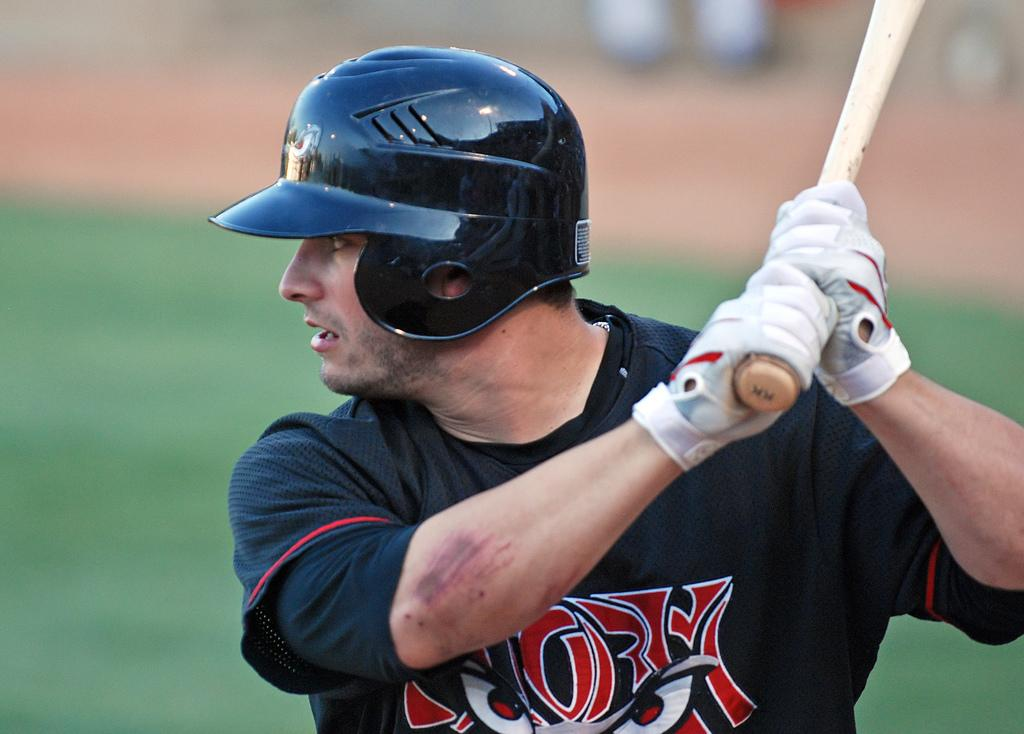What is the main subject of the image? There is a person in the image. What is the person wearing on their upper body? The person is wearing a black T-shirt. What protective gear is the person wearing? The person is wearing a helmet. What other accessory is the person wearing? The person is wearing gloves. What object is the person holding? The person is holding a baseball bat. What can be observed about the background of the image? The background of the image is blurred and green. What type of umbrella is the person holding in the image? There is no umbrella present in the image; the person is holding a baseball bat. What day of the week is depicted in the image? The image does not show a specific day of the week; it is a snapshot of a person wearing a helmet, gloves, and holding a baseball bat. 